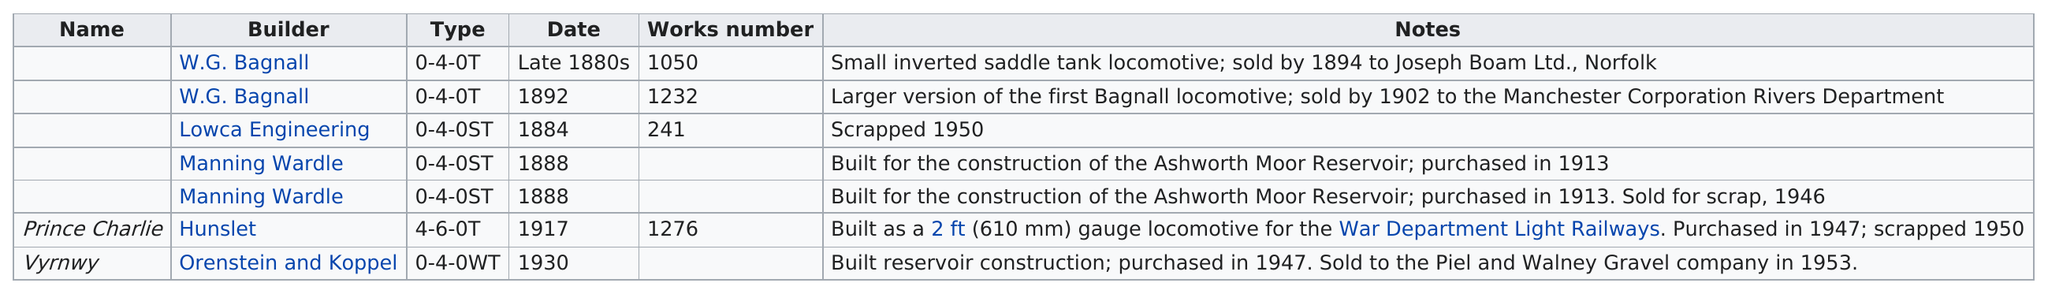Indicate a few pertinent items in this graphic. It is estimated that approximately 2 locomotives were built after the year 1900. Approximately three locomotives were scrapped. Two locomotives were constructed for the construction of the Ashworth Moor Reservoir. The last locomotive to operate was Vyrnwy. The following builders had locomotives scrapped: Lowca Engineering, Manning Wardle, and Hunslet. 